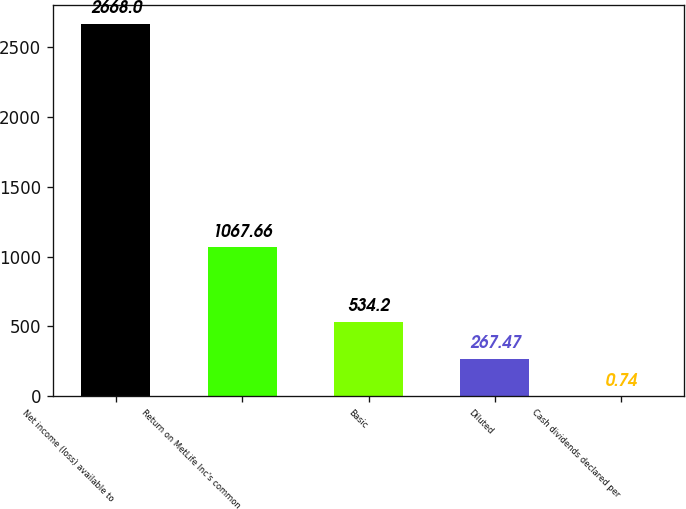Convert chart to OTSL. <chart><loc_0><loc_0><loc_500><loc_500><bar_chart><fcel>Net income (loss) available to<fcel>Return on MetLife Inc's common<fcel>Basic<fcel>Diluted<fcel>Cash dividends declared per<nl><fcel>2668<fcel>1067.66<fcel>534.2<fcel>267.47<fcel>0.74<nl></chart> 